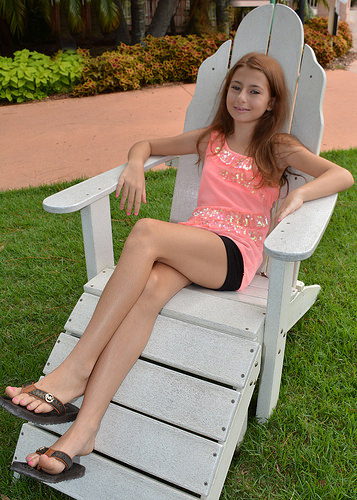<image>
Is there a girl sitting on the grass? No. The girl sitting is not positioned on the grass. They may be near each other, but the girl sitting is not supported by or resting on top of the grass. Where is the plant in relation to the grass? Is it on the grass? No. The plant is not positioned on the grass. They may be near each other, but the plant is not supported by or resting on top of the grass. Is there a girl on the sidewalk? No. The girl is not positioned on the sidewalk. They may be near each other, but the girl is not supported by or resting on top of the sidewalk. 